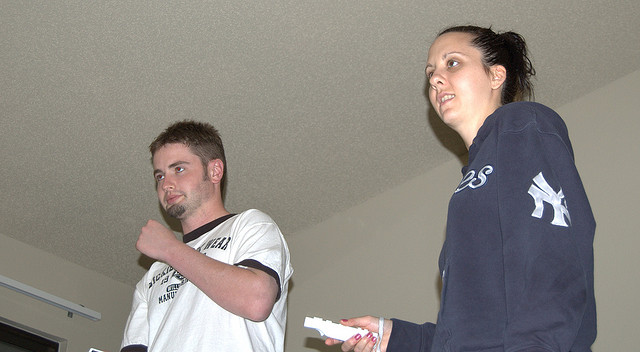Read and extract the text from this image. NY es MANU WEAR 